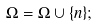<formula> <loc_0><loc_0><loc_500><loc_500>\Omega = \Omega \cup \{ n \} ;</formula> 